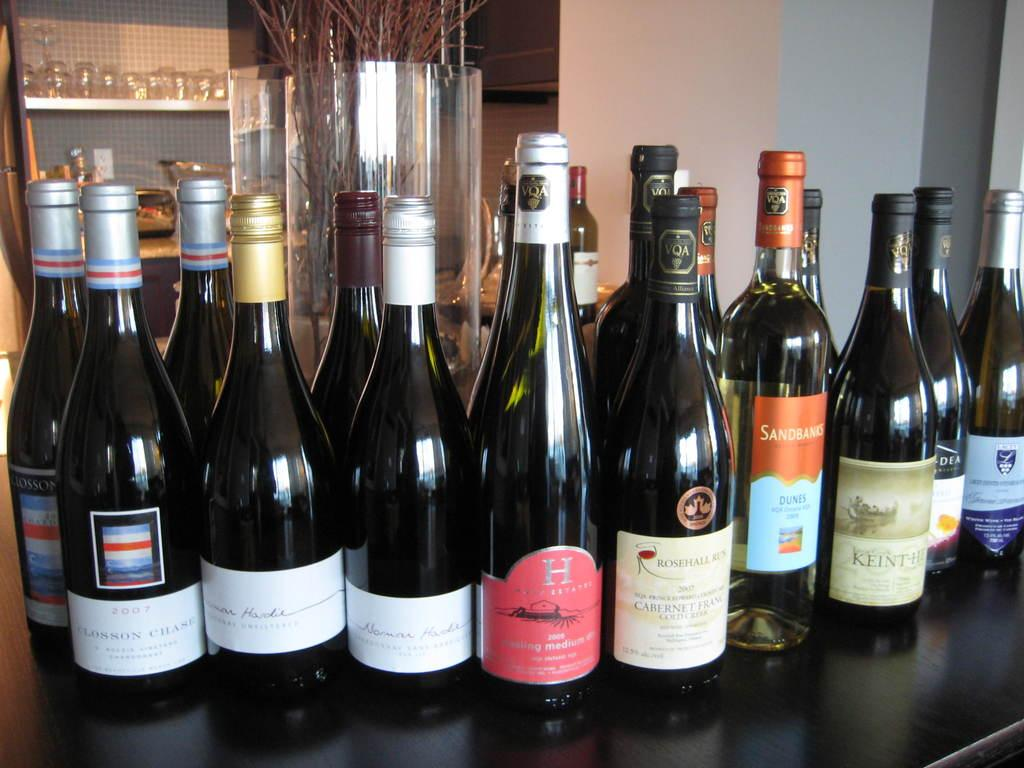<image>
Offer a succinct explanation of the picture presented. the word Rosehall that is on a wine bottle 